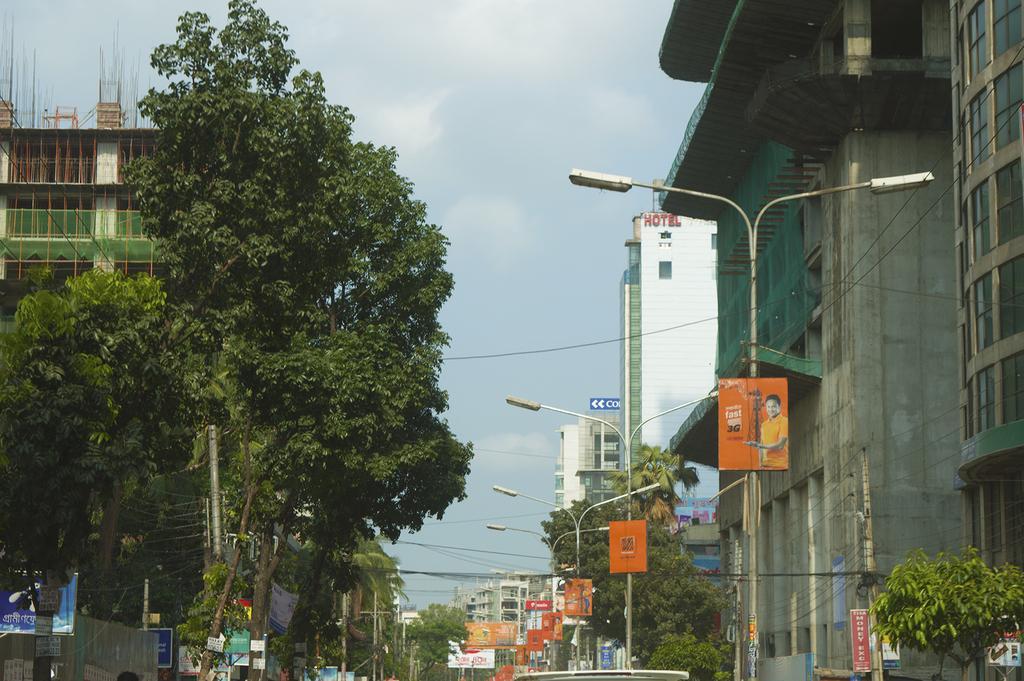How would you summarize this image in a sentence or two? In this picture, on the right there are street light poles, buildings and few posters. On the left, there are trees, buildings and banners. In the background, there are cables, buildings and the sky. 